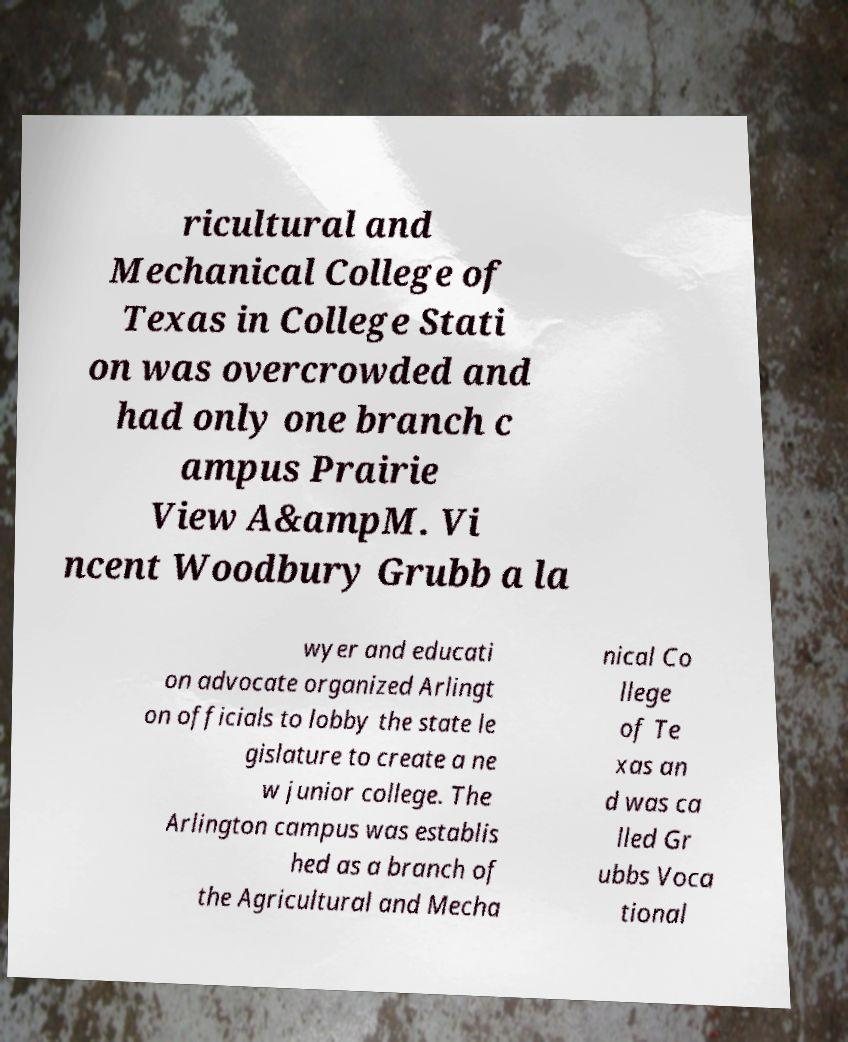Please read and relay the text visible in this image. What does it say? ricultural and Mechanical College of Texas in College Stati on was overcrowded and had only one branch c ampus Prairie View A&ampM. Vi ncent Woodbury Grubb a la wyer and educati on advocate organized Arlingt on officials to lobby the state le gislature to create a ne w junior college. The Arlington campus was establis hed as a branch of the Agricultural and Mecha nical Co llege of Te xas an d was ca lled Gr ubbs Voca tional 